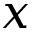<formula> <loc_0><loc_0><loc_500><loc_500>x</formula> 